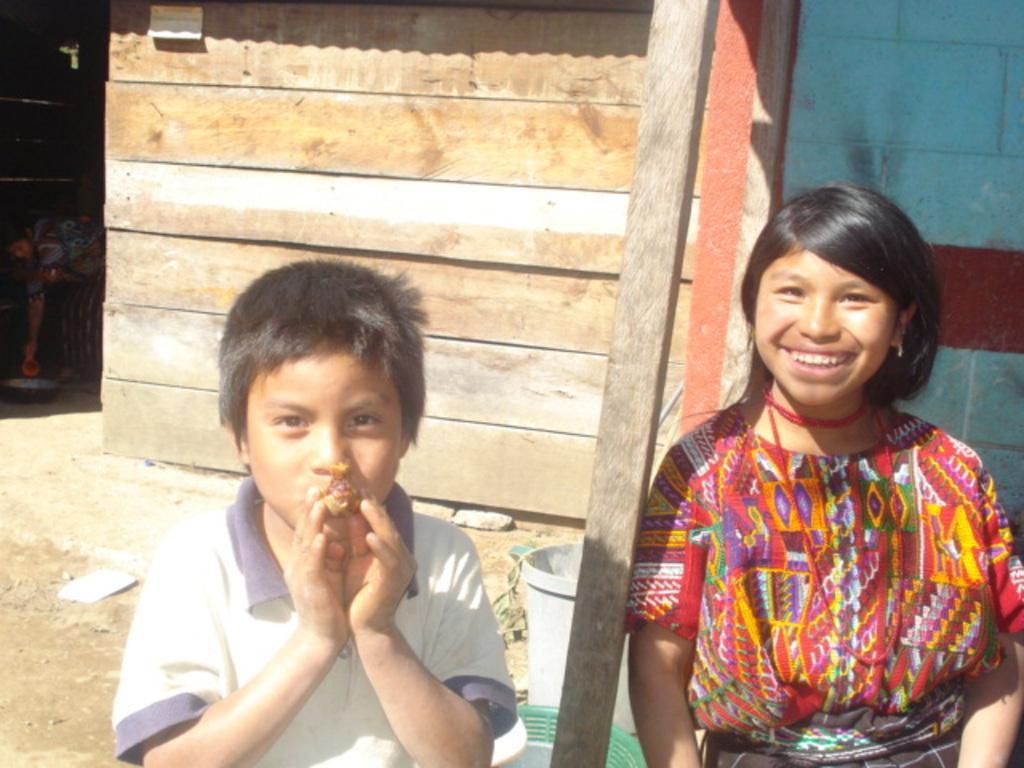How would you summarize this image in a sentence or two? In the foreground of the picture we can see kids, bucket, wooden pole and soil. In the background we can see a brick wall, a wooden house, and stones. On the left we can see a person inside the house. 